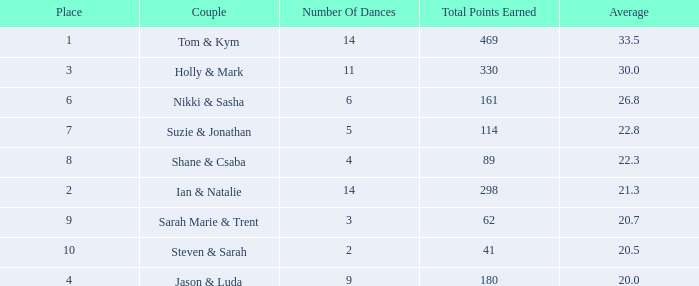What is the number of dances total number if the average is 22.3? 1.0. 